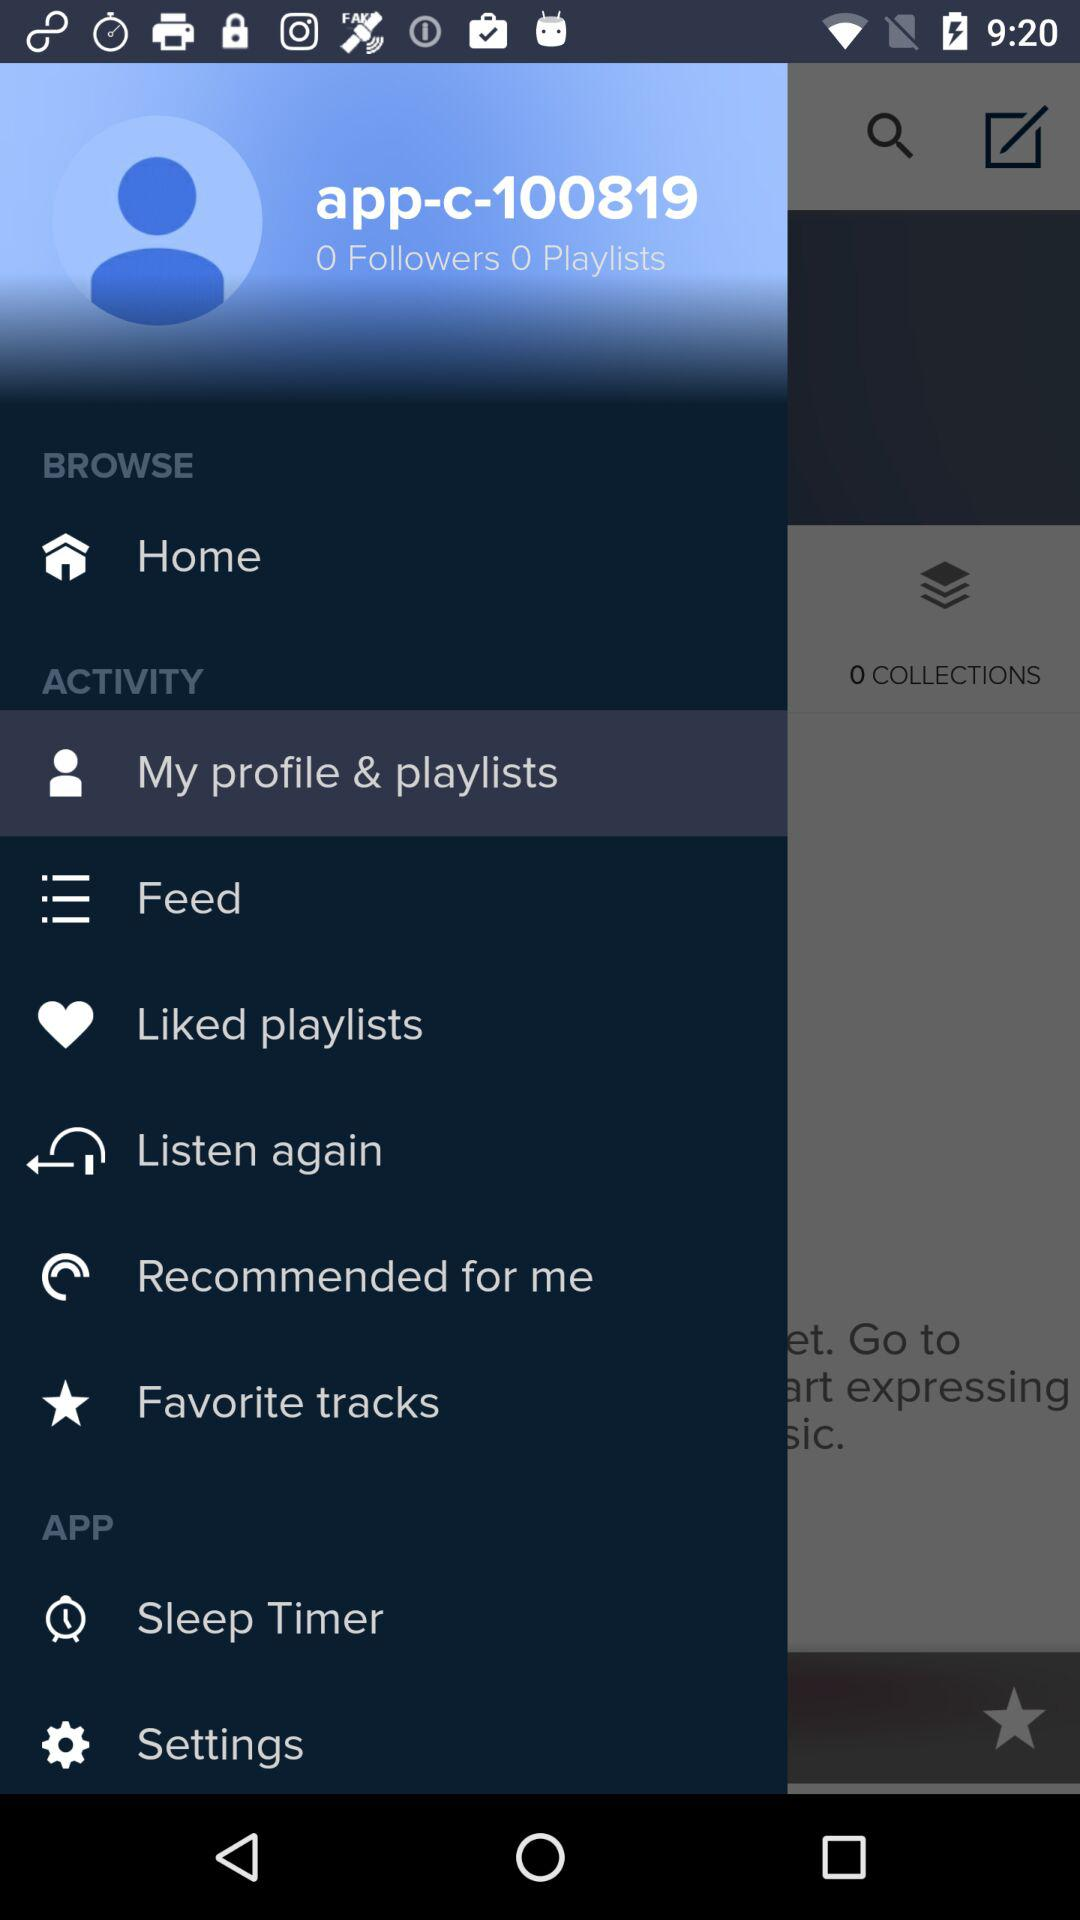How many people are following? The number of followers is 0. 